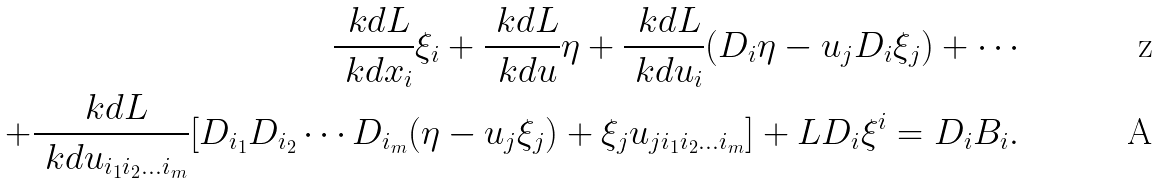<formula> <loc_0><loc_0><loc_500><loc_500>\frac { \ k d L } { \ k d x _ { i } } { \xi } _ { i } + \frac { \ k d L } { \ k d u } \eta + \frac { \ k d L } { \ k d u _ { i } } ( D _ { i } \eta - u _ { j } D _ { i } { \xi } _ { j } ) + \cdots \\ + \frac { \ k d L } { \ k d u _ { i _ { 1 } i _ { 2 } \dots i _ { m } } } [ D _ { i _ { 1 } } D _ { i _ { 2 } } \cdots D _ { i _ { m } } ( \eta - u _ { j } { \xi } _ { j } ) + { \xi } _ { j } u _ { j i _ { 1 } i _ { 2 } \dots i _ { m } } ] + L D _ { i } { \xi } ^ { i } = D _ { i } B _ { i } .</formula> 